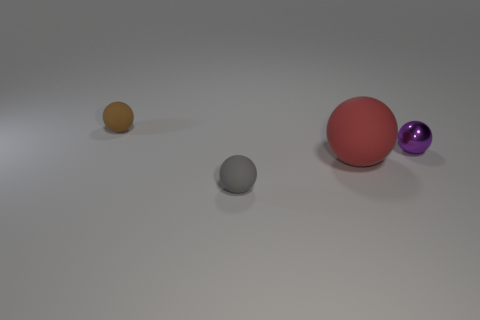Add 2 tiny purple balls. How many objects exist? 6 Subtract all big red rubber spheres. How many spheres are left? 3 Subtract 3 balls. How many balls are left? 1 Subtract all gray balls. How many balls are left? 3 Subtract 0 green spheres. How many objects are left? 4 Subtract all purple spheres. Subtract all cyan cylinders. How many spheres are left? 3 Subtract all red balls. Subtract all large gray cylinders. How many objects are left? 3 Add 1 gray spheres. How many gray spheres are left? 2 Add 1 red things. How many red things exist? 2 